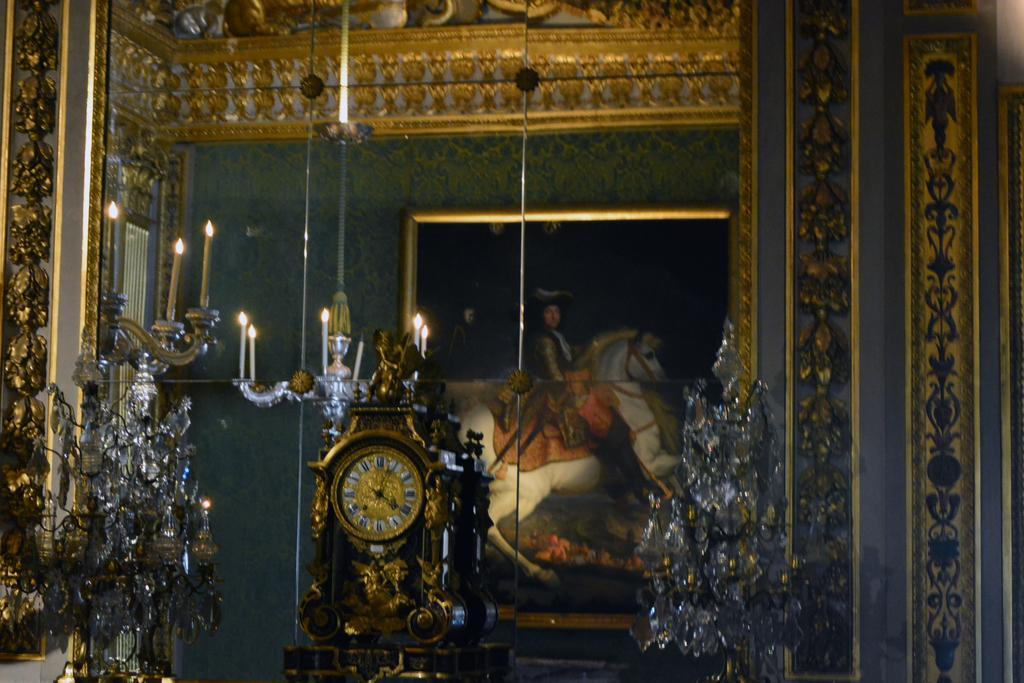Describe this image in one or two sentences. In this picture we can observe a clock placed on the desk. There are two lamps on either sides of the clock. We can observe candles behind the clock. We can observe a glass. In the background there is a photo frame fixed to the wall. 